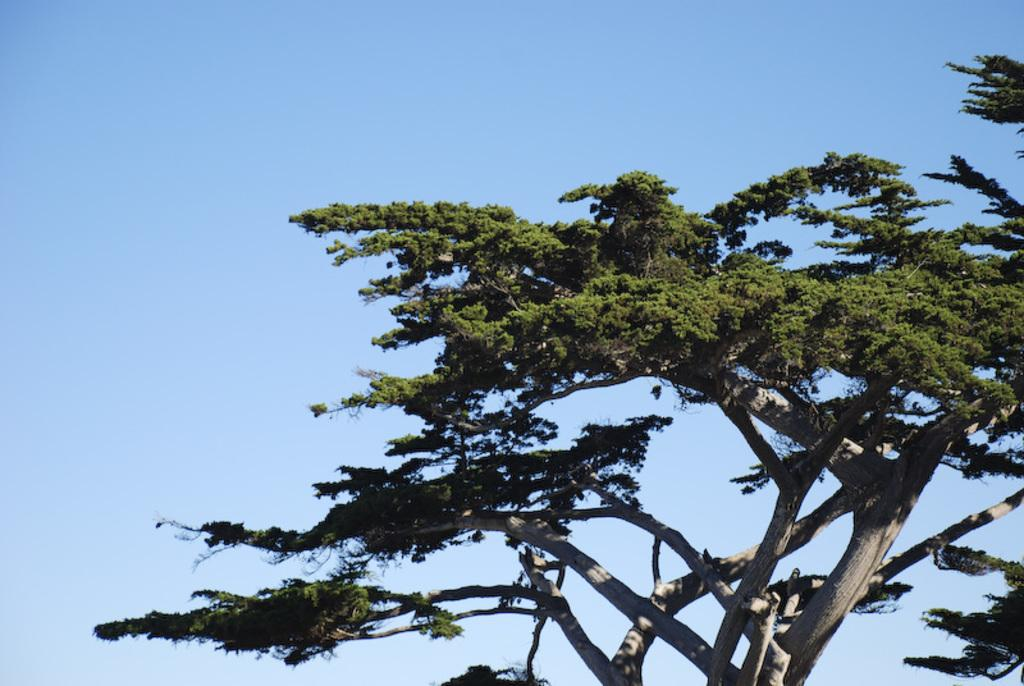What is located in the front of the image? There is a tree in the front of the image. What can be seen in the background of the image? The sky is visible in the background of the image. What type of magic is being performed in the image? There is no magic or any indication of magic being performed in the image; it features a tree and the sky. How many books are visible in the image? There are no books present in the image. 